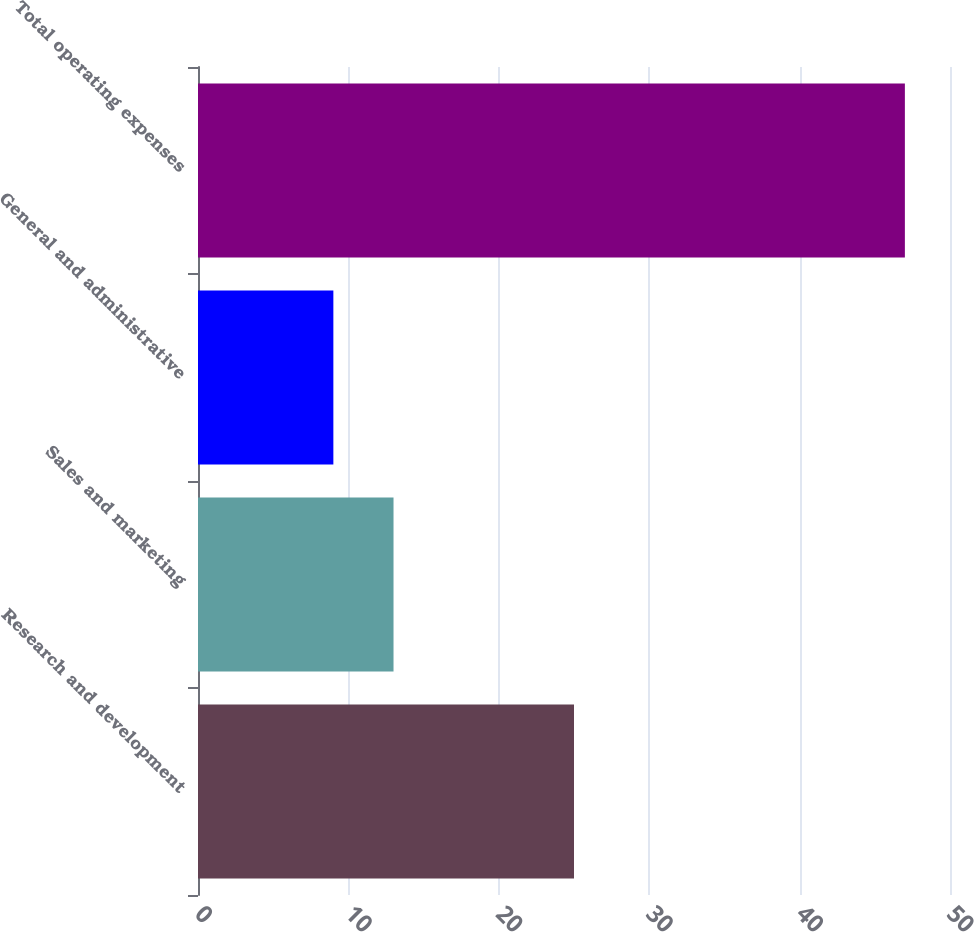Convert chart. <chart><loc_0><loc_0><loc_500><loc_500><bar_chart><fcel>Research and development<fcel>Sales and marketing<fcel>General and administrative<fcel>Total operating expenses<nl><fcel>25<fcel>13<fcel>9<fcel>47<nl></chart> 